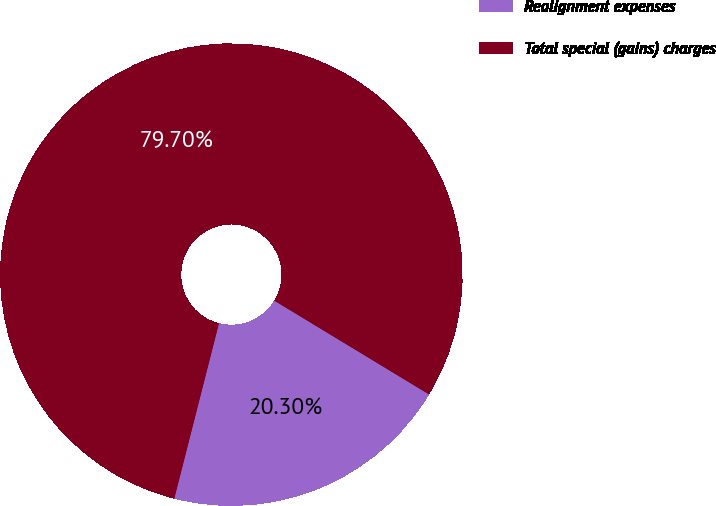Convert chart. <chart><loc_0><loc_0><loc_500><loc_500><pie_chart><fcel>Realignment expenses<fcel>Total special (gains) charges<nl><fcel>20.3%<fcel>79.7%<nl></chart> 